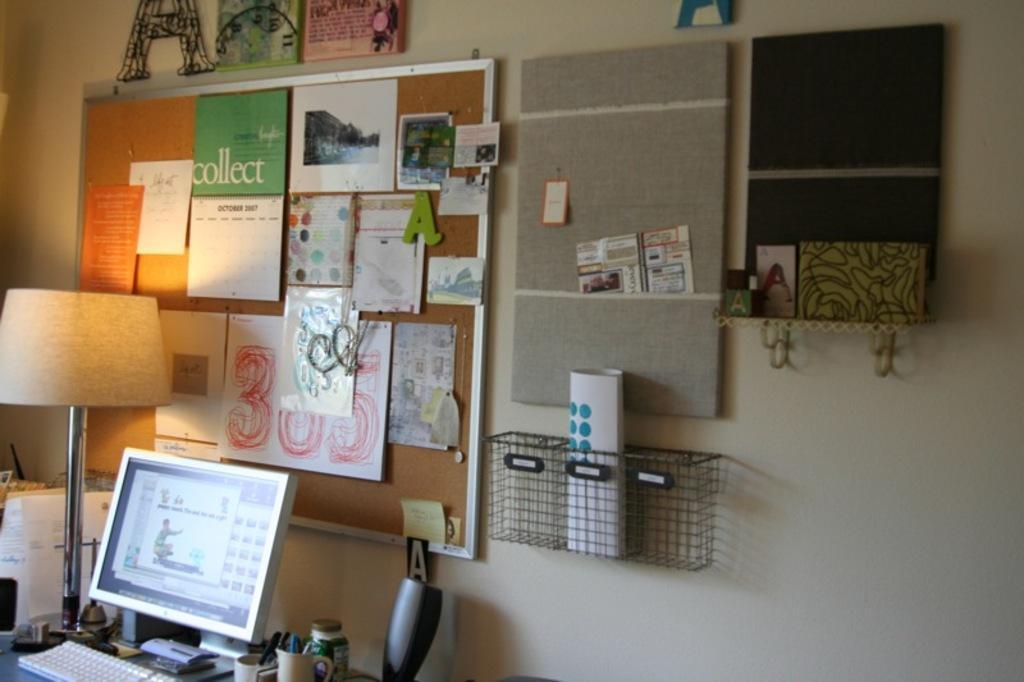In one or two sentences, can you explain what this image depicts? In this image we can see a monitor, keyboard, mugs, bottle, lamp, boards, posters, frames, mesh container, papers, and objects. In the background there is a wall. 